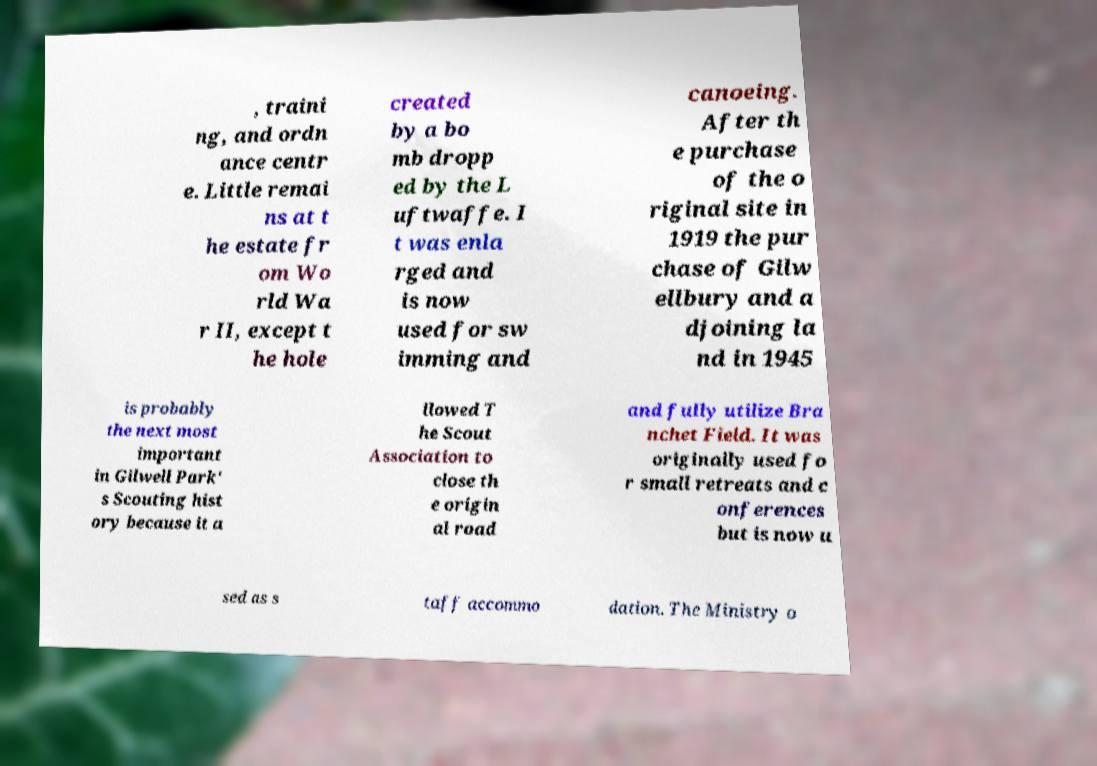What messages or text are displayed in this image? I need them in a readable, typed format. , traini ng, and ordn ance centr e. Little remai ns at t he estate fr om Wo rld Wa r II, except t he hole created by a bo mb dropp ed by the L uftwaffe. I t was enla rged and is now used for sw imming and canoeing. After th e purchase of the o riginal site in 1919 the pur chase of Gilw ellbury and a djoining la nd in 1945 is probably the next most important in Gilwell Park' s Scouting hist ory because it a llowed T he Scout Association to close th e origin al road and fully utilize Bra nchet Field. It was originally used fo r small retreats and c onferences but is now u sed as s taff accommo dation. The Ministry o 